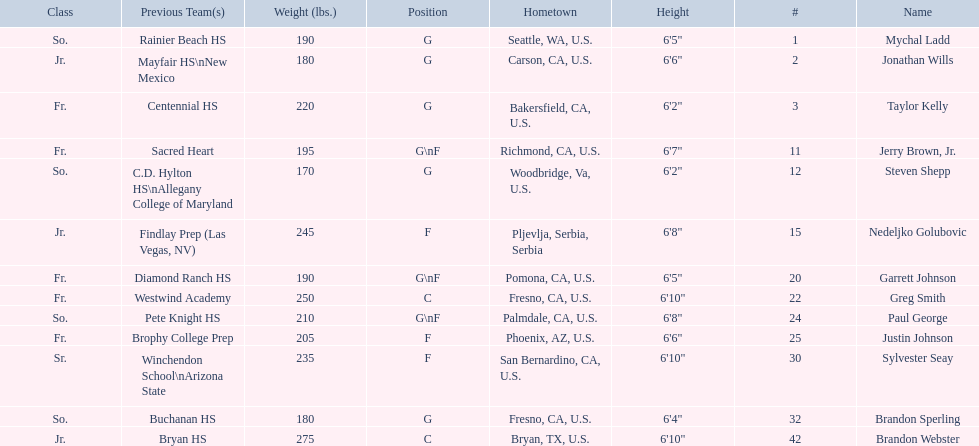Which positions are so.? G, G, G\nF, G. Which weights are g 190, 170, 180. What height is under 6 3' 6'2". What is the name Steven Shepp. 